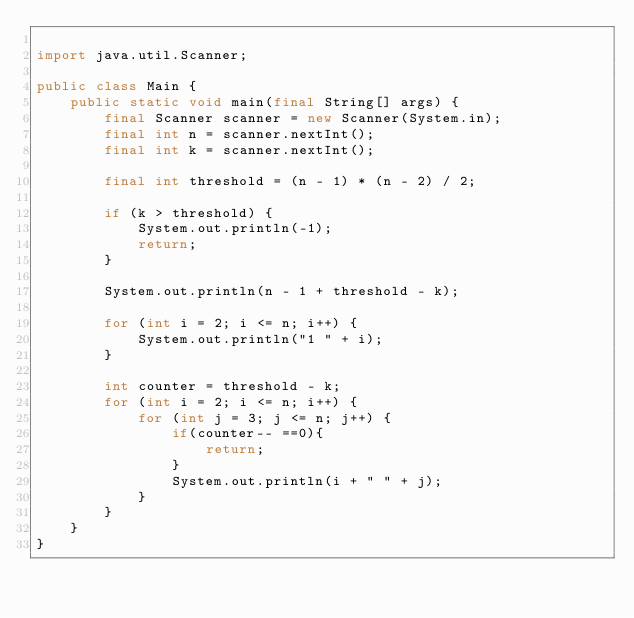<code> <loc_0><loc_0><loc_500><loc_500><_Java_>
import java.util.Scanner;

public class Main {
    public static void main(final String[] args) {
        final Scanner scanner = new Scanner(System.in);
        final int n = scanner.nextInt();
        final int k = scanner.nextInt();

        final int threshold = (n - 1) * (n - 2) / 2;

        if (k > threshold) {
            System.out.println(-1);
            return;
        }

        System.out.println(n - 1 + threshold - k);

        for (int i = 2; i <= n; i++) {
            System.out.println("1 " + i);
        }

        int counter = threshold - k;
        for (int i = 2; i <= n; i++) {
            for (int j = 3; j <= n; j++) {
                if(counter-- ==0){
                    return;
                }
                System.out.println(i + " " + j);
            }
        }
    }
}
</code> 